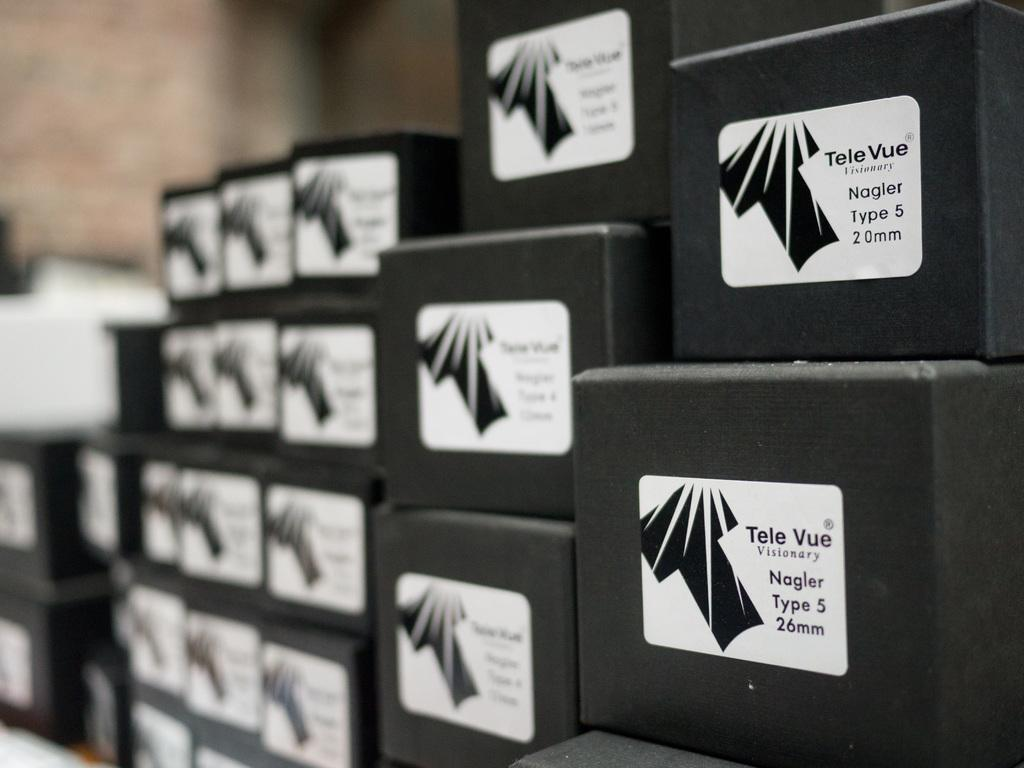Provide a one-sentence caption for the provided image. Several boxes are stacked of different mm of Tele Vue Visionary Nagler Type 5. 